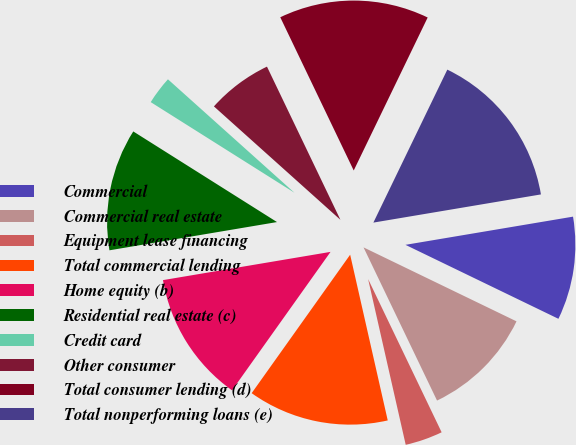Convert chart to OTSL. <chart><loc_0><loc_0><loc_500><loc_500><pie_chart><fcel>Commercial<fcel>Commercial real estate<fcel>Equipment lease financing<fcel>Total commercial lending<fcel>Home equity (b)<fcel>Residential real estate (c)<fcel>Credit card<fcel>Other consumer<fcel>Total consumer lending (d)<fcel>Total nonperforming loans (e)<nl><fcel>9.82%<fcel>10.71%<fcel>3.57%<fcel>13.39%<fcel>12.5%<fcel>11.61%<fcel>2.68%<fcel>6.25%<fcel>14.28%<fcel>15.18%<nl></chart> 